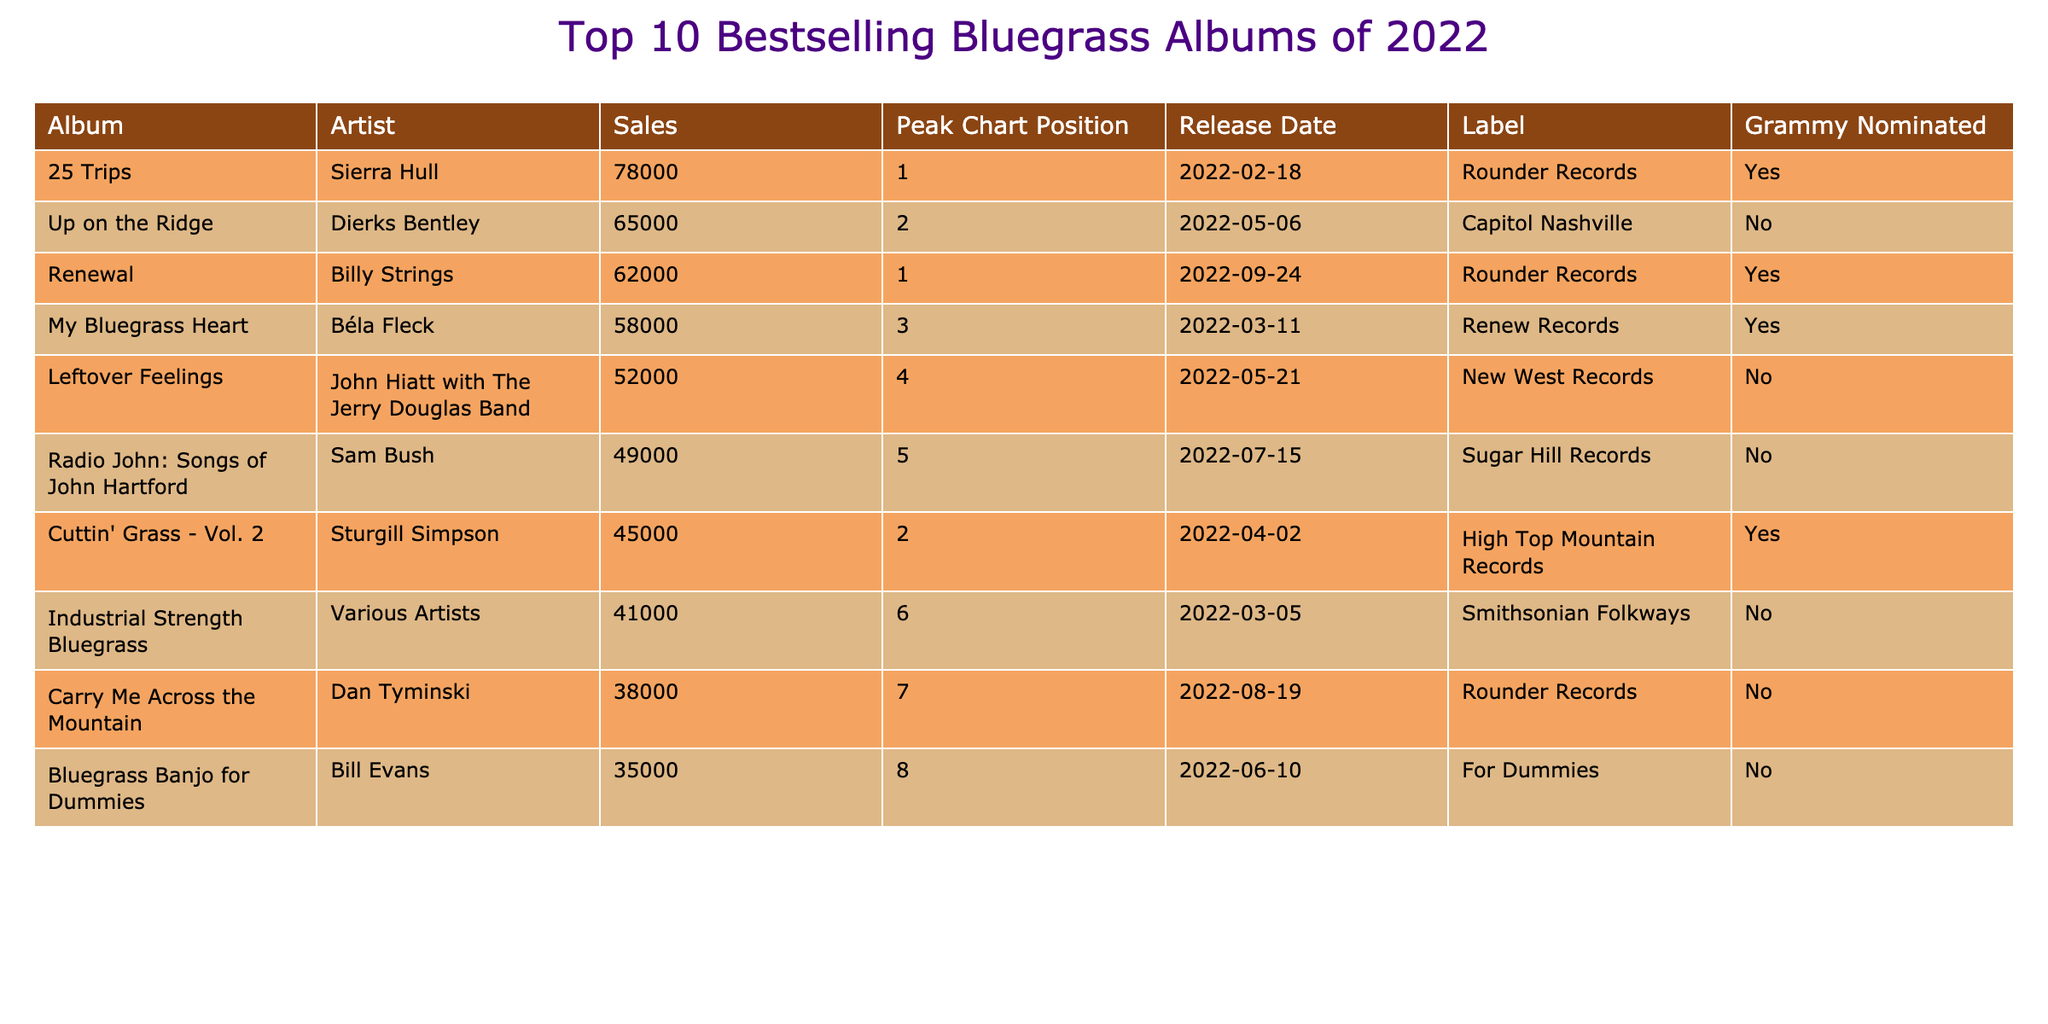What is the highest-selling bluegrass album of 2022? The data shows that "25 Trips" by Sierra Hull has sales of 78,000, which is the highest number compared to other albums listed.
Answer: 25 Trips Which artist has an album that peaked at position 1? There are two albums that peaked at position 1: "25 Trips" by Sierra Hull and "Renewal" by Billy Strings.
Answer: Sierra Hull and Billy Strings What is the total sales of the top 3 bestselling albums? To find the total sales of the top 3 albums, we add their sales: 78,000 (Sierra Hull) + 62,000 (Billy Strings) + 58,000 (Béla Fleck) = 198,000.
Answer: 198,000 How many albums were released by Rounder Records? There are three albums from Rounder Records in the table: "25 Trips," "Renewal," and "Carry Me Across the Mountain."
Answer: 3 Which album had the lowest sales, and how many copies were sold? "Bluegrass Banjo for Dummies" by Bill Evans had the lowest sales at 35,000 copies, which is the least among all the listed albums.
Answer: Bluegrass Banjo for Dummies, 35,000 Is "My Bluegrass Heart" a Grammy-nominated album? According to the table, "My Bluegrass Heart" by Béla Fleck is marked as Grammy nominated, indicating it received a nomination.
Answer: Yes How many albums in the top 10 are Grammy nominated? The table indicates that there are 4 albums highlighted as Grammy nominated: "25 Trips," "Renewal," "My Bluegrass Heart," and "Cuttin' Grass - Vol. 2."
Answer: 4 What is the average sales of the albums released by Rounder Records? The total sales for Rounder Records albums are: 78,000 (Sierra Hull) + 62,000 (Billy Strings) + 38,000 (Dan Tyminski) = 178,000. There are 3 albums, so average sales = 178,000 / 3 ≈ 59,333.
Answer: 59,333 Which album was released on June 10, 2022? The table shows that "Bluegrass Banjo for Dummies" by Bill Evans was released on June 10, 2022.
Answer: Bluegrass Banjo for Dummies What is the difference in sales between the top-selling album and the one in fifth place? The top-selling album is "25 Trips" with 78,000 sales, while the fifth album, "Radio John: Songs of John Hartford," has 49,000 sales. The difference is 78,000 - 49,000 = 29,000.
Answer: 29,000 